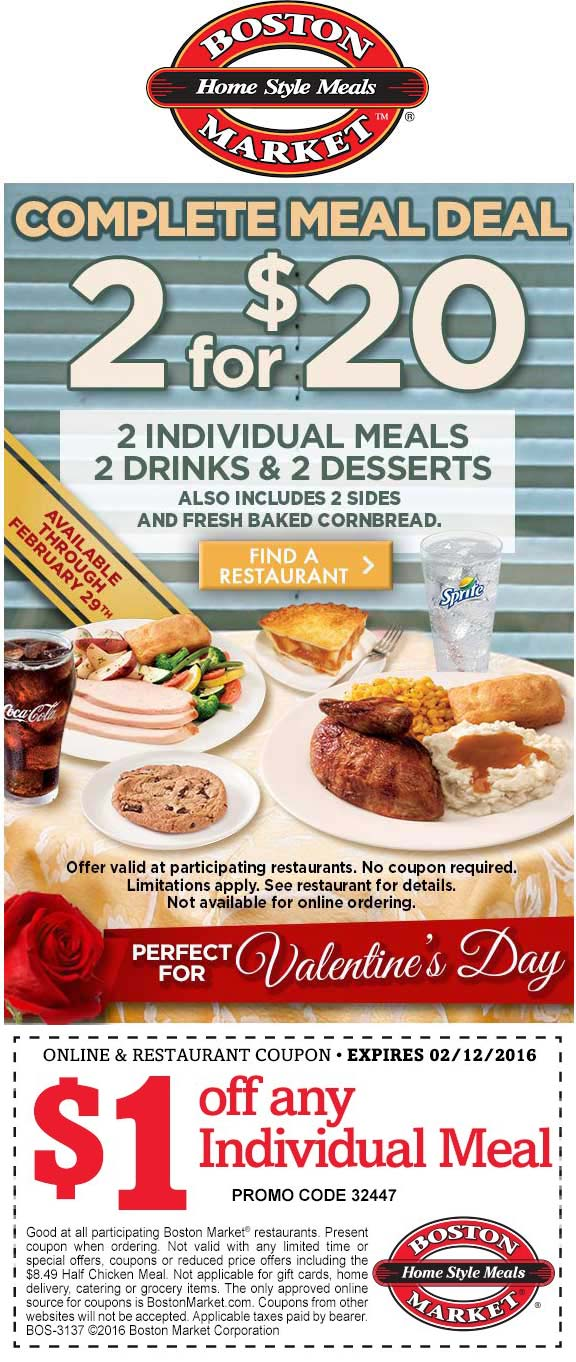Considering the expiry date of the coupon, what might be the significance of the chosen time frame for the promotion? The expiry date of the coupon is February 12, 2016, which is significant because it is just before Valentine's Day, a holiday often associated with dining out or special meals. The promotion's time frame, starting from January 29th and ending on Valentine's Day, is likely chosen to capitalize on the increase in people looking for dining deals during this romantic holiday period. The use of a red rose and subtle heart graphics in the advertisement further aligns with the Valentine's Day theme, suggesting that the meal deal is positioned as an affordable and cozy dining option for couples or individuals celebrating the occasion. 